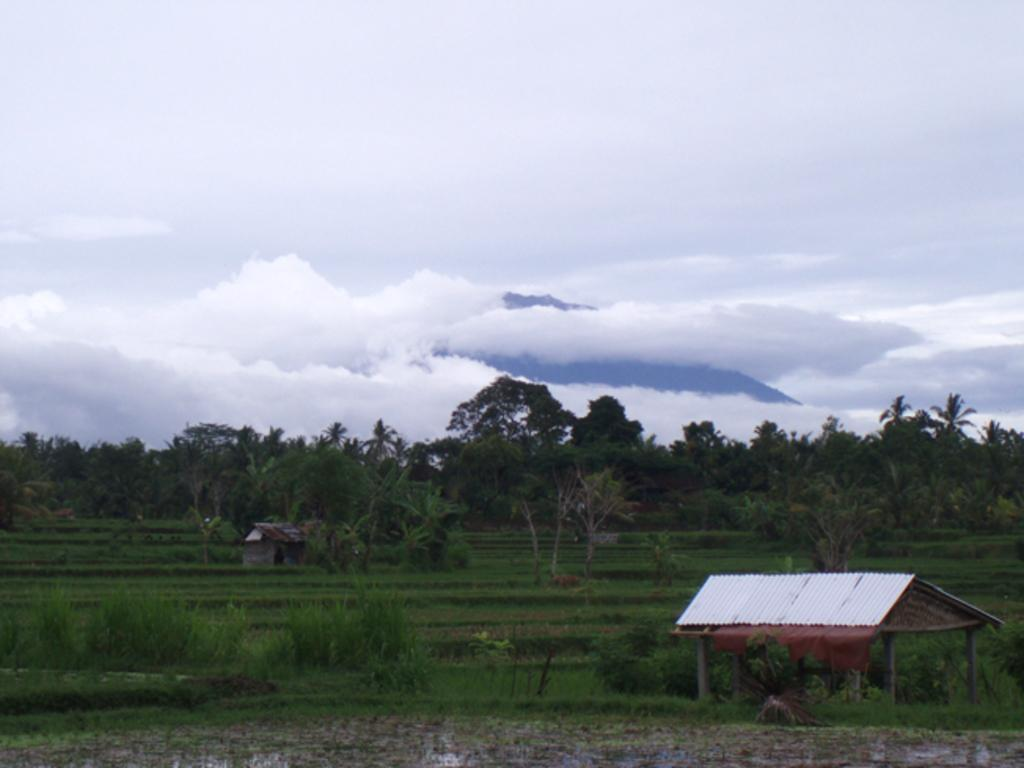What type of structure is in the image? There is a shed in the image. What can be seen in the background of the image? The background of the image includes grass and trees. What is the color of the grass in the image? The grass is green in color. What is visible in the sky in the image? The sky is visible in the image and has both white and blue colors. What type of oatmeal is being served in the image? There is no oatmeal present in the image; it features a shed, grass, trees, and a sky with white and blue colors. What causes the bells to burst in the image? There are no bells present in the image, and therefore, they cannot burst. 